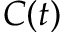<formula> <loc_0><loc_0><loc_500><loc_500>C ( t )</formula> 